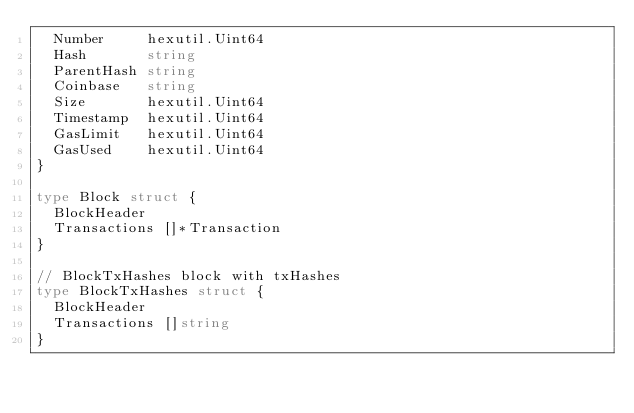<code> <loc_0><loc_0><loc_500><loc_500><_Go_>	Number     hexutil.Uint64
	Hash       string
	ParentHash string
	Coinbase   string
	Size       hexutil.Uint64
	Timestamp  hexutil.Uint64
	GasLimit   hexutil.Uint64
	GasUsed    hexutil.Uint64
}

type Block struct {
	BlockHeader
	Transactions []*Transaction
}

// BlockTxHashes block with txHashes
type BlockTxHashes struct {
	BlockHeader
	Transactions []string
}
</code> 